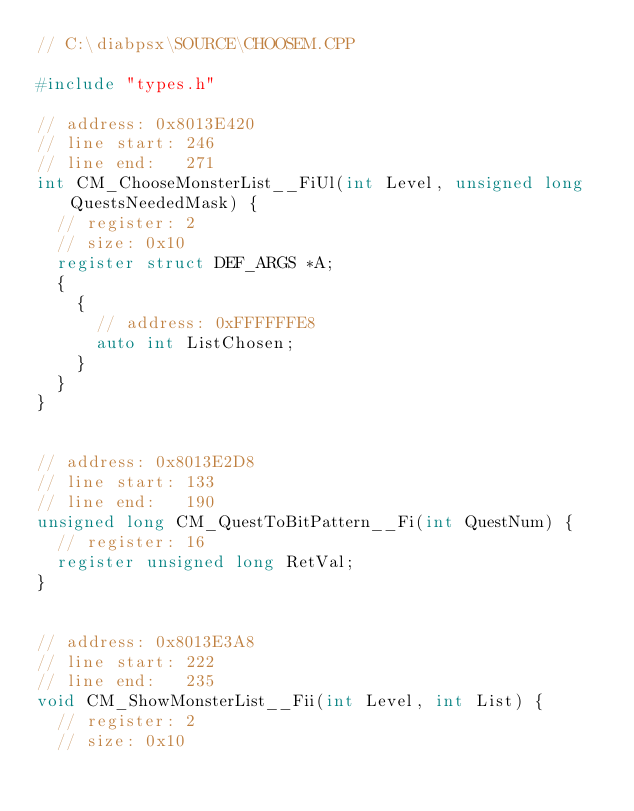Convert code to text. <code><loc_0><loc_0><loc_500><loc_500><_C++_>// C:\diabpsx\SOURCE\CHOOSEM.CPP

#include "types.h"

// address: 0x8013E420
// line start: 246
// line end:   271
int CM_ChooseMonsterList__FiUl(int Level, unsigned long QuestsNeededMask) {
	// register: 2
	// size: 0x10
	register struct DEF_ARGS *A;
	{
		{
			// address: 0xFFFFFFE8
			auto int ListChosen;
		}
	}
}


// address: 0x8013E2D8
// line start: 133
// line end:   190
unsigned long CM_QuestToBitPattern__Fi(int QuestNum) {
	// register: 16
	register unsigned long RetVal;
}


// address: 0x8013E3A8
// line start: 222
// line end:   235
void CM_ShowMonsterList__Fii(int Level, int List) {
	// register: 2
	// size: 0x10</code> 